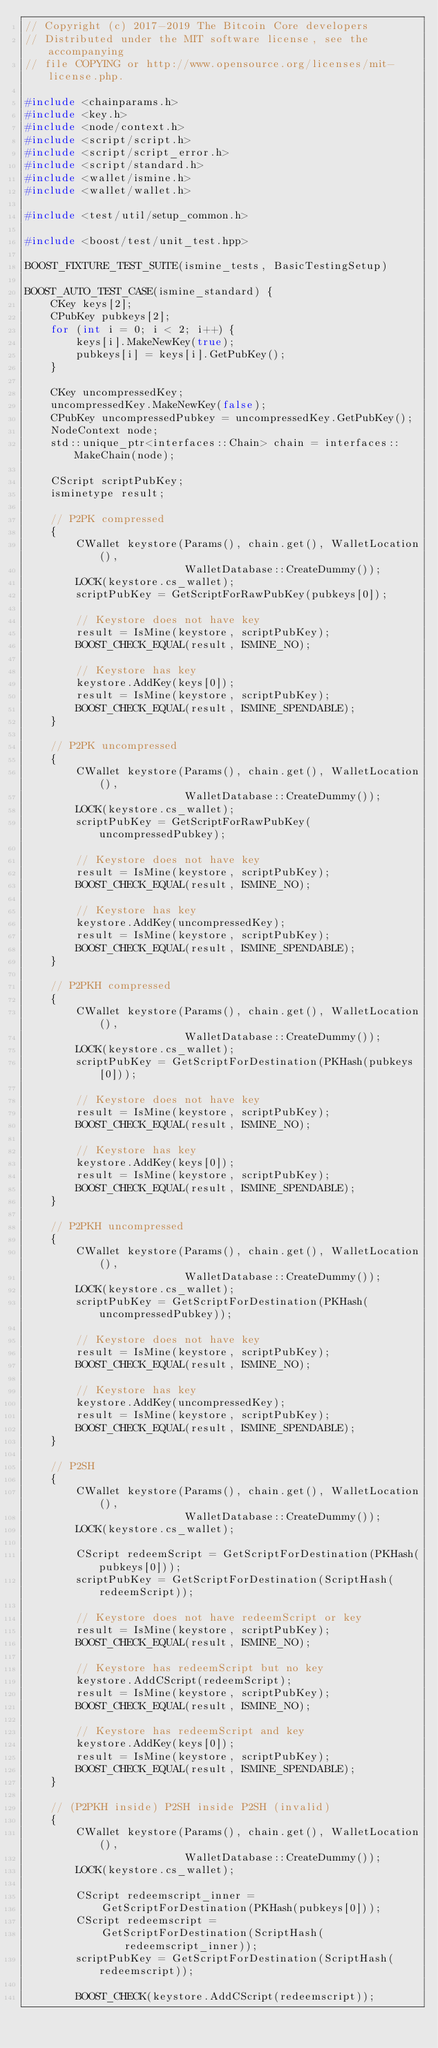Convert code to text. <code><loc_0><loc_0><loc_500><loc_500><_C++_>// Copyright (c) 2017-2019 The Bitcoin Core developers
// Distributed under the MIT software license, see the accompanying
// file COPYING or http://www.opensource.org/licenses/mit-license.php.

#include <chainparams.h>
#include <key.h>
#include <node/context.h>
#include <script/script.h>
#include <script/script_error.h>
#include <script/standard.h>
#include <wallet/ismine.h>
#include <wallet/wallet.h>

#include <test/util/setup_common.h>

#include <boost/test/unit_test.hpp>

BOOST_FIXTURE_TEST_SUITE(ismine_tests, BasicTestingSetup)

BOOST_AUTO_TEST_CASE(ismine_standard) {
    CKey keys[2];
    CPubKey pubkeys[2];
    for (int i = 0; i < 2; i++) {
        keys[i].MakeNewKey(true);
        pubkeys[i] = keys[i].GetPubKey();
    }

    CKey uncompressedKey;
    uncompressedKey.MakeNewKey(false);
    CPubKey uncompressedPubkey = uncompressedKey.GetPubKey();
    NodeContext node;
    std::unique_ptr<interfaces::Chain> chain = interfaces::MakeChain(node);

    CScript scriptPubKey;
    isminetype result;

    // P2PK compressed
    {
        CWallet keystore(Params(), chain.get(), WalletLocation(),
                         WalletDatabase::CreateDummy());
        LOCK(keystore.cs_wallet);
        scriptPubKey = GetScriptForRawPubKey(pubkeys[0]);

        // Keystore does not have key
        result = IsMine(keystore, scriptPubKey);
        BOOST_CHECK_EQUAL(result, ISMINE_NO);

        // Keystore has key
        keystore.AddKey(keys[0]);
        result = IsMine(keystore, scriptPubKey);
        BOOST_CHECK_EQUAL(result, ISMINE_SPENDABLE);
    }

    // P2PK uncompressed
    {
        CWallet keystore(Params(), chain.get(), WalletLocation(),
                         WalletDatabase::CreateDummy());
        LOCK(keystore.cs_wallet);
        scriptPubKey = GetScriptForRawPubKey(uncompressedPubkey);

        // Keystore does not have key
        result = IsMine(keystore, scriptPubKey);
        BOOST_CHECK_EQUAL(result, ISMINE_NO);

        // Keystore has key
        keystore.AddKey(uncompressedKey);
        result = IsMine(keystore, scriptPubKey);
        BOOST_CHECK_EQUAL(result, ISMINE_SPENDABLE);
    }

    // P2PKH compressed
    {
        CWallet keystore(Params(), chain.get(), WalletLocation(),
                         WalletDatabase::CreateDummy());
        LOCK(keystore.cs_wallet);
        scriptPubKey = GetScriptForDestination(PKHash(pubkeys[0]));

        // Keystore does not have key
        result = IsMine(keystore, scriptPubKey);
        BOOST_CHECK_EQUAL(result, ISMINE_NO);

        // Keystore has key
        keystore.AddKey(keys[0]);
        result = IsMine(keystore, scriptPubKey);
        BOOST_CHECK_EQUAL(result, ISMINE_SPENDABLE);
    }

    // P2PKH uncompressed
    {
        CWallet keystore(Params(), chain.get(), WalletLocation(),
                         WalletDatabase::CreateDummy());
        LOCK(keystore.cs_wallet);
        scriptPubKey = GetScriptForDestination(PKHash(uncompressedPubkey));

        // Keystore does not have key
        result = IsMine(keystore, scriptPubKey);
        BOOST_CHECK_EQUAL(result, ISMINE_NO);

        // Keystore has key
        keystore.AddKey(uncompressedKey);
        result = IsMine(keystore, scriptPubKey);
        BOOST_CHECK_EQUAL(result, ISMINE_SPENDABLE);
    }

    // P2SH
    {
        CWallet keystore(Params(), chain.get(), WalletLocation(),
                         WalletDatabase::CreateDummy());
        LOCK(keystore.cs_wallet);

        CScript redeemScript = GetScriptForDestination(PKHash(pubkeys[0]));
        scriptPubKey = GetScriptForDestination(ScriptHash(redeemScript));

        // Keystore does not have redeemScript or key
        result = IsMine(keystore, scriptPubKey);
        BOOST_CHECK_EQUAL(result, ISMINE_NO);

        // Keystore has redeemScript but no key
        keystore.AddCScript(redeemScript);
        result = IsMine(keystore, scriptPubKey);
        BOOST_CHECK_EQUAL(result, ISMINE_NO);

        // Keystore has redeemScript and key
        keystore.AddKey(keys[0]);
        result = IsMine(keystore, scriptPubKey);
        BOOST_CHECK_EQUAL(result, ISMINE_SPENDABLE);
    }

    // (P2PKH inside) P2SH inside P2SH (invalid)
    {
        CWallet keystore(Params(), chain.get(), WalletLocation(),
                         WalletDatabase::CreateDummy());
        LOCK(keystore.cs_wallet);

        CScript redeemscript_inner =
            GetScriptForDestination(PKHash(pubkeys[0]));
        CScript redeemscript =
            GetScriptForDestination(ScriptHash(redeemscript_inner));
        scriptPubKey = GetScriptForDestination(ScriptHash(redeemscript));

        BOOST_CHECK(keystore.AddCScript(redeemscript));</code> 